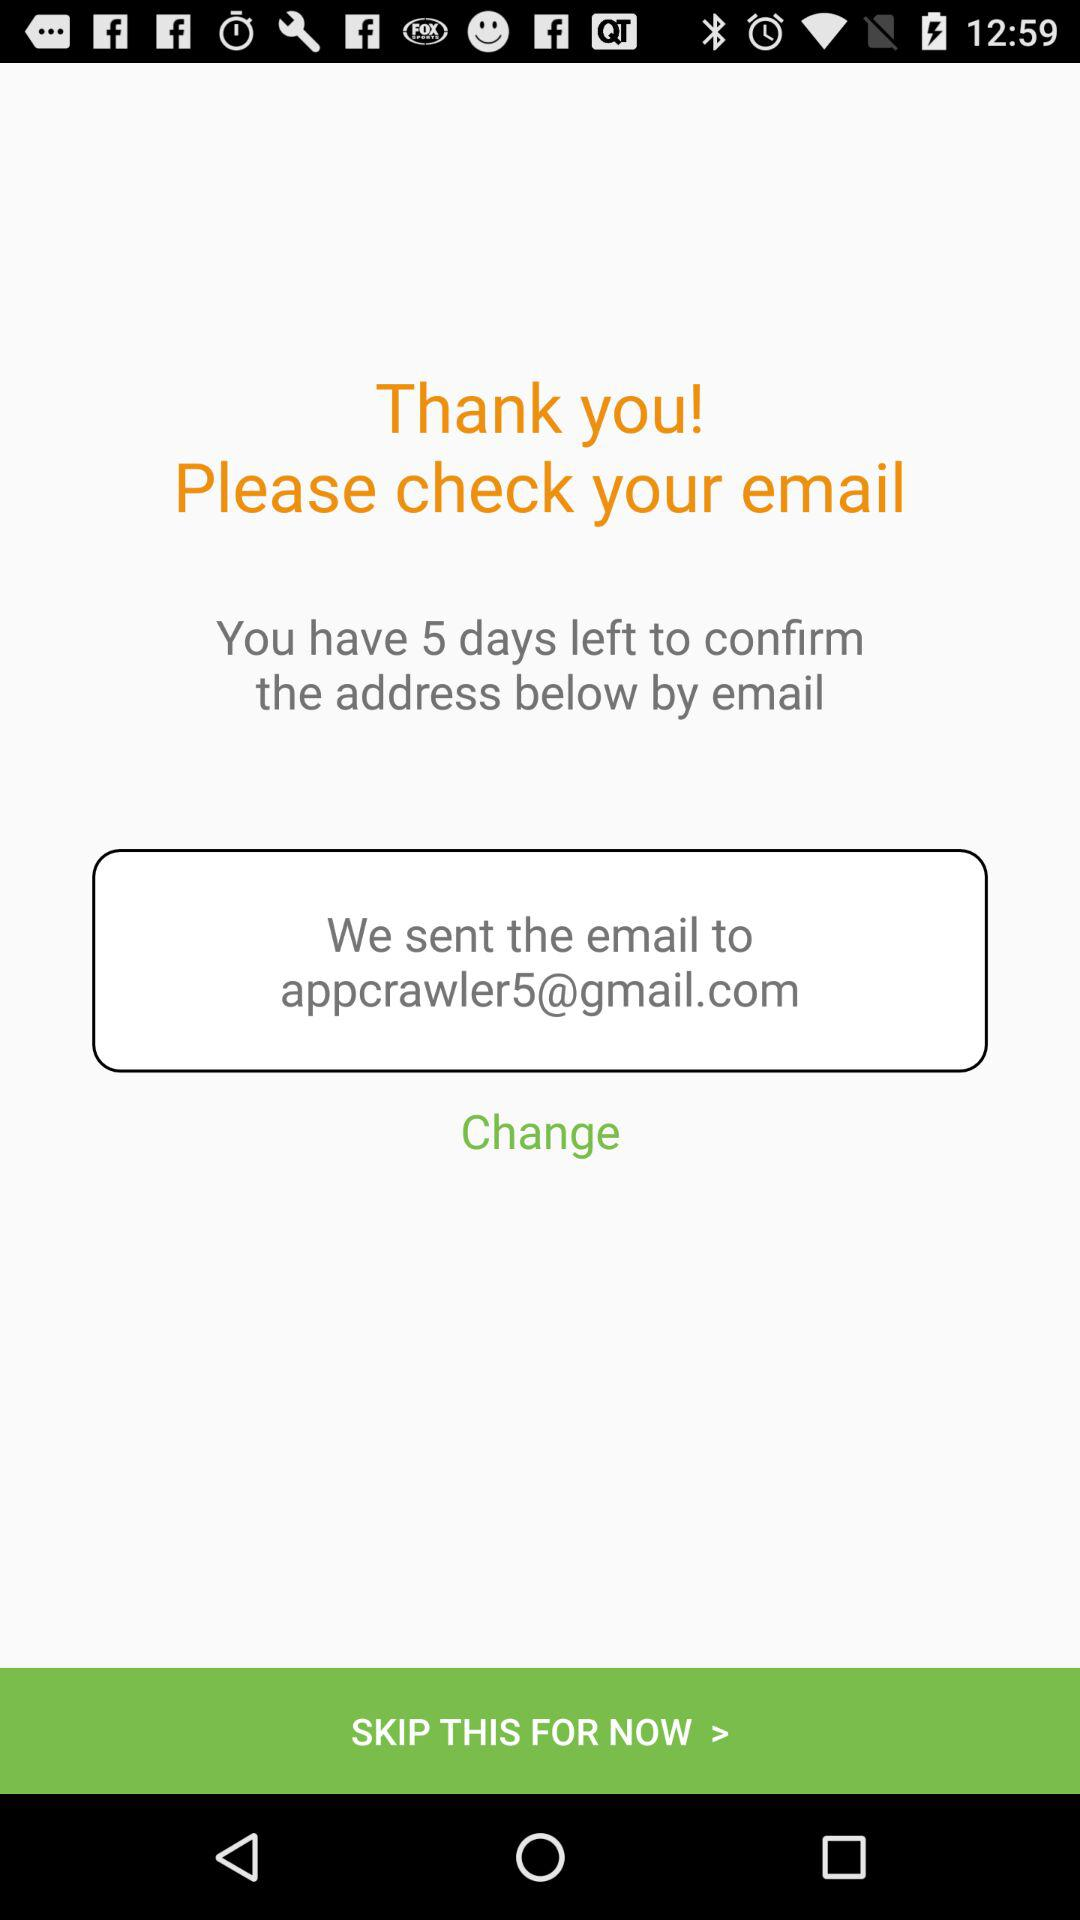How many days are left to confirm the address by email? There are 5 days left. 